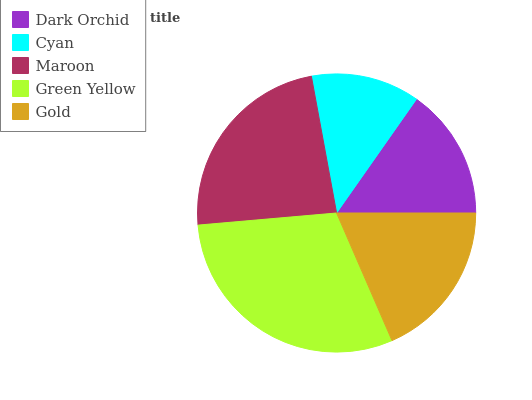Is Cyan the minimum?
Answer yes or no. Yes. Is Green Yellow the maximum?
Answer yes or no. Yes. Is Maroon the minimum?
Answer yes or no. No. Is Maroon the maximum?
Answer yes or no. No. Is Maroon greater than Cyan?
Answer yes or no. Yes. Is Cyan less than Maroon?
Answer yes or no. Yes. Is Cyan greater than Maroon?
Answer yes or no. No. Is Maroon less than Cyan?
Answer yes or no. No. Is Gold the high median?
Answer yes or no. Yes. Is Gold the low median?
Answer yes or no. Yes. Is Dark Orchid the high median?
Answer yes or no. No. Is Green Yellow the low median?
Answer yes or no. No. 